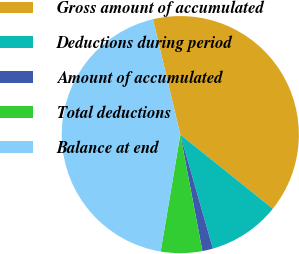Convert chart to OTSL. <chart><loc_0><loc_0><loc_500><loc_500><pie_chart><fcel>Gross amount of accumulated<fcel>Deductions during period<fcel>Amount of accumulated<fcel>Total deductions<fcel>Balance at end<nl><fcel>39.47%<fcel>9.81%<fcel>1.45%<fcel>5.63%<fcel>43.65%<nl></chart> 